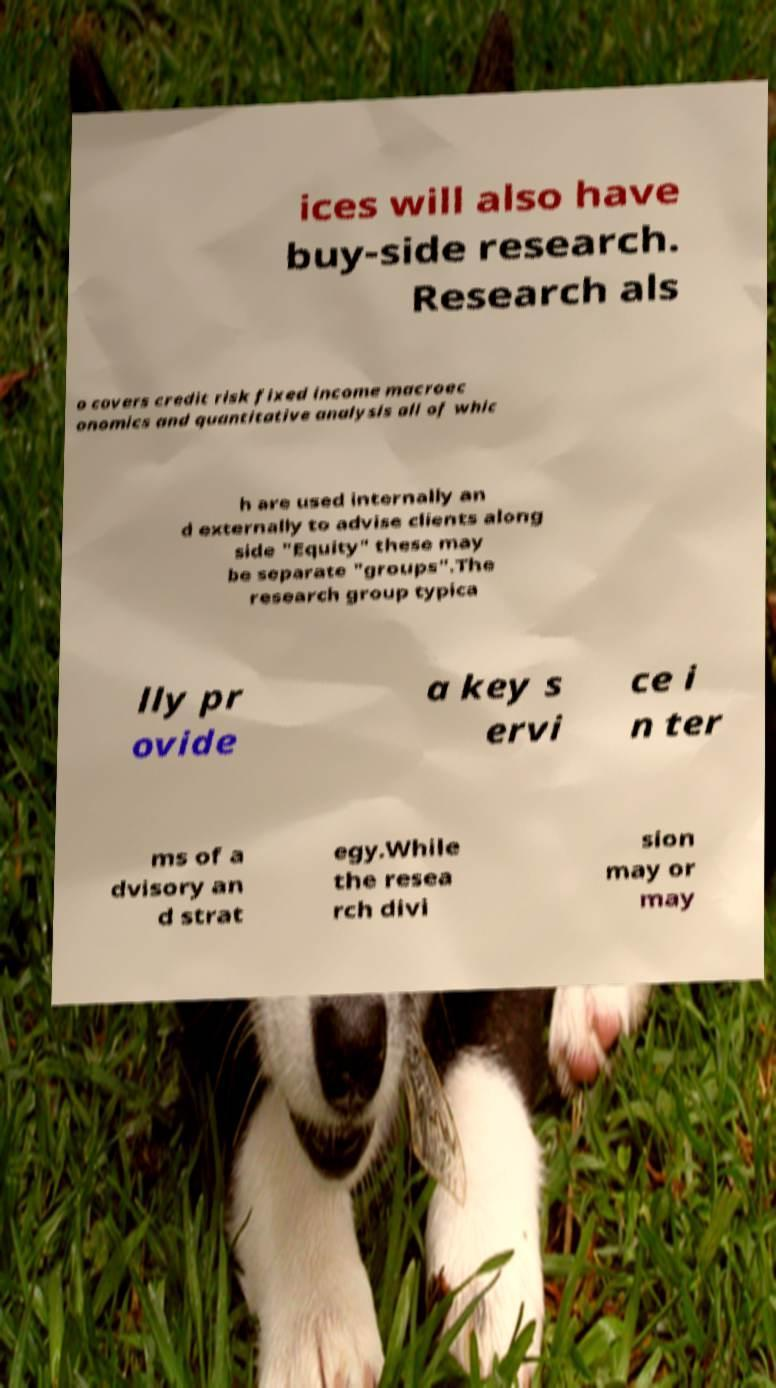What messages or text are displayed in this image? I need them in a readable, typed format. ices will also have buy-side research. Research als o covers credit risk fixed income macroec onomics and quantitative analysis all of whic h are used internally an d externally to advise clients along side "Equity" these may be separate "groups".The research group typica lly pr ovide a key s ervi ce i n ter ms of a dvisory an d strat egy.While the resea rch divi sion may or may 